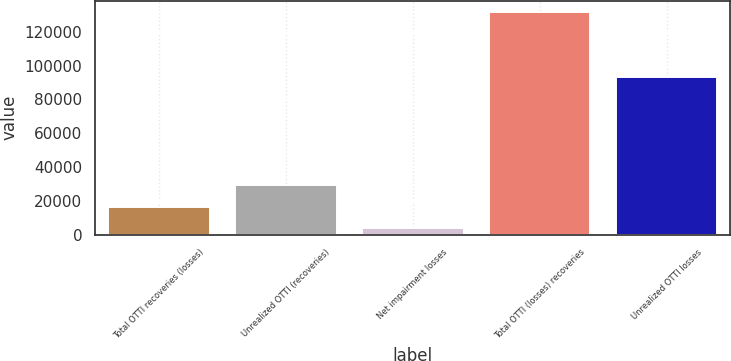<chart> <loc_0><loc_0><loc_500><loc_500><bar_chart><fcel>Total OTTI recoveries (losses)<fcel>Unrealized OTTI (recoveries)<fcel>Net impairment losses<fcel>Total OTTI (losses) recoveries<fcel>Unrealized OTTI losses<nl><fcel>16608.4<fcel>29418.8<fcel>3798<fcel>131902<fcel>93491<nl></chart> 